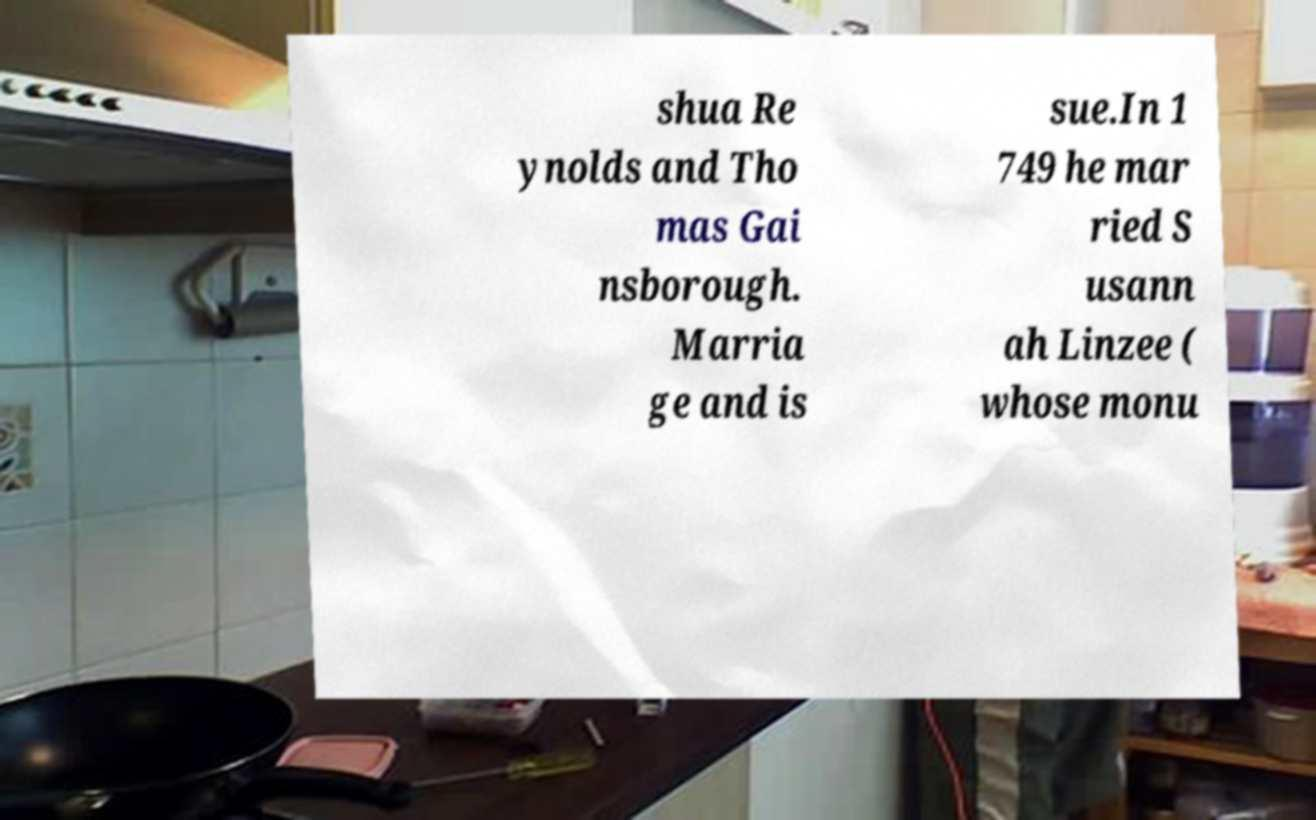What messages or text are displayed in this image? I need them in a readable, typed format. shua Re ynolds and Tho mas Gai nsborough. Marria ge and is sue.In 1 749 he mar ried S usann ah Linzee ( whose monu 